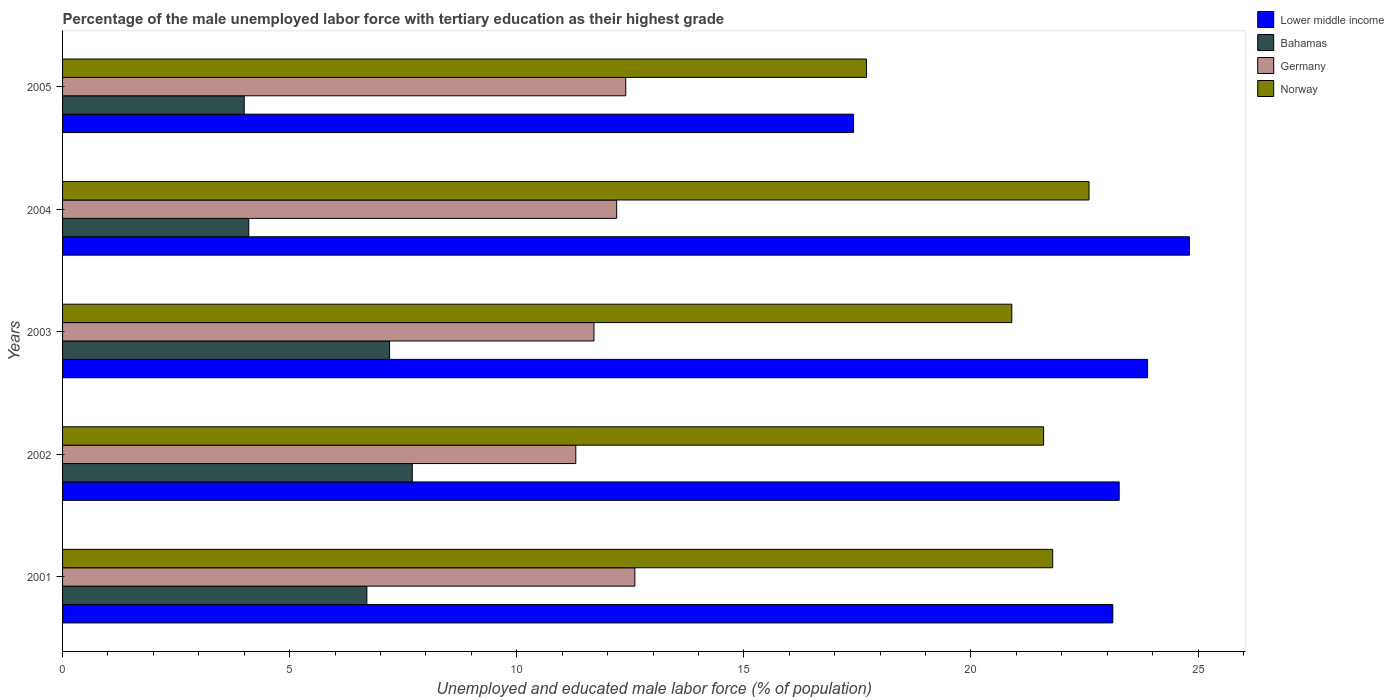How many groups of bars are there?
Your answer should be very brief. 5. Are the number of bars per tick equal to the number of legend labels?
Provide a succinct answer. Yes. Are the number of bars on each tick of the Y-axis equal?
Keep it short and to the point. Yes. How many bars are there on the 4th tick from the top?
Your answer should be very brief. 4. What is the percentage of the unemployed male labor force with tertiary education in Germany in 2002?
Provide a succinct answer. 11.3. Across all years, what is the maximum percentage of the unemployed male labor force with tertiary education in Germany?
Keep it short and to the point. 12.6. Across all years, what is the minimum percentage of the unemployed male labor force with tertiary education in Lower middle income?
Keep it short and to the point. 17.42. In which year was the percentage of the unemployed male labor force with tertiary education in Bahamas minimum?
Your answer should be compact. 2005. What is the total percentage of the unemployed male labor force with tertiary education in Germany in the graph?
Offer a terse response. 60.2. What is the difference between the percentage of the unemployed male labor force with tertiary education in Germany in 2004 and the percentage of the unemployed male labor force with tertiary education in Lower middle income in 2002?
Provide a short and direct response. -11.06. What is the average percentage of the unemployed male labor force with tertiary education in Bahamas per year?
Offer a terse response. 5.94. In the year 2005, what is the difference between the percentage of the unemployed male labor force with tertiary education in Norway and percentage of the unemployed male labor force with tertiary education in Germany?
Provide a succinct answer. 5.3. In how many years, is the percentage of the unemployed male labor force with tertiary education in Germany greater than 10 %?
Your answer should be very brief. 5. What is the ratio of the percentage of the unemployed male labor force with tertiary education in Norway in 2002 to that in 2005?
Offer a very short reply. 1.22. Is the percentage of the unemployed male labor force with tertiary education in Bahamas in 2002 less than that in 2003?
Make the answer very short. No. Is the difference between the percentage of the unemployed male labor force with tertiary education in Norway in 2001 and 2003 greater than the difference between the percentage of the unemployed male labor force with tertiary education in Germany in 2001 and 2003?
Provide a short and direct response. No. What is the difference between the highest and the second highest percentage of the unemployed male labor force with tertiary education in Germany?
Your answer should be very brief. 0.2. What is the difference between the highest and the lowest percentage of the unemployed male labor force with tertiary education in Norway?
Make the answer very short. 4.9. Is the sum of the percentage of the unemployed male labor force with tertiary education in Lower middle income in 2001 and 2002 greater than the maximum percentage of the unemployed male labor force with tertiary education in Norway across all years?
Your response must be concise. Yes. What does the 1st bar from the top in 2005 represents?
Keep it short and to the point. Norway. What does the 2nd bar from the bottom in 2001 represents?
Provide a succinct answer. Bahamas. Is it the case that in every year, the sum of the percentage of the unemployed male labor force with tertiary education in Germany and percentage of the unemployed male labor force with tertiary education in Norway is greater than the percentage of the unemployed male labor force with tertiary education in Lower middle income?
Your answer should be very brief. Yes. How many years are there in the graph?
Your response must be concise. 5. What is the difference between two consecutive major ticks on the X-axis?
Provide a short and direct response. 5. Are the values on the major ticks of X-axis written in scientific E-notation?
Provide a succinct answer. No. Does the graph contain any zero values?
Make the answer very short. No. How many legend labels are there?
Give a very brief answer. 4. What is the title of the graph?
Your answer should be compact. Percentage of the male unemployed labor force with tertiary education as their highest grade. Does "Trinidad and Tobago" appear as one of the legend labels in the graph?
Provide a succinct answer. No. What is the label or title of the X-axis?
Your response must be concise. Unemployed and educated male labor force (% of population). What is the label or title of the Y-axis?
Offer a very short reply. Years. What is the Unemployed and educated male labor force (% of population) of Lower middle income in 2001?
Offer a terse response. 23.12. What is the Unemployed and educated male labor force (% of population) of Bahamas in 2001?
Your answer should be very brief. 6.7. What is the Unemployed and educated male labor force (% of population) of Germany in 2001?
Your answer should be compact. 12.6. What is the Unemployed and educated male labor force (% of population) of Norway in 2001?
Provide a succinct answer. 21.8. What is the Unemployed and educated male labor force (% of population) in Lower middle income in 2002?
Your answer should be very brief. 23.26. What is the Unemployed and educated male labor force (% of population) in Bahamas in 2002?
Your response must be concise. 7.7. What is the Unemployed and educated male labor force (% of population) of Germany in 2002?
Your response must be concise. 11.3. What is the Unemployed and educated male labor force (% of population) in Norway in 2002?
Your answer should be very brief. 21.6. What is the Unemployed and educated male labor force (% of population) of Lower middle income in 2003?
Ensure brevity in your answer.  23.89. What is the Unemployed and educated male labor force (% of population) of Bahamas in 2003?
Provide a succinct answer. 7.2. What is the Unemployed and educated male labor force (% of population) in Germany in 2003?
Provide a short and direct response. 11.7. What is the Unemployed and educated male labor force (% of population) of Norway in 2003?
Your answer should be compact. 20.9. What is the Unemployed and educated male labor force (% of population) in Lower middle income in 2004?
Ensure brevity in your answer.  24.81. What is the Unemployed and educated male labor force (% of population) of Bahamas in 2004?
Your answer should be very brief. 4.1. What is the Unemployed and educated male labor force (% of population) of Germany in 2004?
Provide a succinct answer. 12.2. What is the Unemployed and educated male labor force (% of population) of Norway in 2004?
Ensure brevity in your answer.  22.6. What is the Unemployed and educated male labor force (% of population) in Lower middle income in 2005?
Your response must be concise. 17.42. What is the Unemployed and educated male labor force (% of population) in Bahamas in 2005?
Ensure brevity in your answer.  4. What is the Unemployed and educated male labor force (% of population) in Germany in 2005?
Provide a short and direct response. 12.4. What is the Unemployed and educated male labor force (% of population) of Norway in 2005?
Your response must be concise. 17.7. Across all years, what is the maximum Unemployed and educated male labor force (% of population) in Lower middle income?
Ensure brevity in your answer.  24.81. Across all years, what is the maximum Unemployed and educated male labor force (% of population) in Bahamas?
Provide a succinct answer. 7.7. Across all years, what is the maximum Unemployed and educated male labor force (% of population) in Germany?
Keep it short and to the point. 12.6. Across all years, what is the maximum Unemployed and educated male labor force (% of population) of Norway?
Keep it short and to the point. 22.6. Across all years, what is the minimum Unemployed and educated male labor force (% of population) of Lower middle income?
Provide a short and direct response. 17.42. Across all years, what is the minimum Unemployed and educated male labor force (% of population) of Germany?
Provide a succinct answer. 11.3. Across all years, what is the minimum Unemployed and educated male labor force (% of population) of Norway?
Your answer should be compact. 17.7. What is the total Unemployed and educated male labor force (% of population) in Lower middle income in the graph?
Give a very brief answer. 112.5. What is the total Unemployed and educated male labor force (% of population) of Bahamas in the graph?
Offer a terse response. 29.7. What is the total Unemployed and educated male labor force (% of population) in Germany in the graph?
Your response must be concise. 60.2. What is the total Unemployed and educated male labor force (% of population) of Norway in the graph?
Offer a terse response. 104.6. What is the difference between the Unemployed and educated male labor force (% of population) of Lower middle income in 2001 and that in 2002?
Make the answer very short. -0.14. What is the difference between the Unemployed and educated male labor force (% of population) in Bahamas in 2001 and that in 2002?
Keep it short and to the point. -1. What is the difference between the Unemployed and educated male labor force (% of population) of Lower middle income in 2001 and that in 2003?
Offer a terse response. -0.77. What is the difference between the Unemployed and educated male labor force (% of population) of Bahamas in 2001 and that in 2003?
Keep it short and to the point. -0.5. What is the difference between the Unemployed and educated male labor force (% of population) in Germany in 2001 and that in 2003?
Make the answer very short. 0.9. What is the difference between the Unemployed and educated male labor force (% of population) of Lower middle income in 2001 and that in 2004?
Provide a succinct answer. -1.69. What is the difference between the Unemployed and educated male labor force (% of population) of Bahamas in 2001 and that in 2004?
Your response must be concise. 2.6. What is the difference between the Unemployed and educated male labor force (% of population) in Germany in 2001 and that in 2004?
Your response must be concise. 0.4. What is the difference between the Unemployed and educated male labor force (% of population) of Lower middle income in 2001 and that in 2005?
Give a very brief answer. 5.71. What is the difference between the Unemployed and educated male labor force (% of population) of Germany in 2001 and that in 2005?
Offer a very short reply. 0.2. What is the difference between the Unemployed and educated male labor force (% of population) of Lower middle income in 2002 and that in 2003?
Your answer should be very brief. -0.62. What is the difference between the Unemployed and educated male labor force (% of population) in Bahamas in 2002 and that in 2003?
Provide a short and direct response. 0.5. What is the difference between the Unemployed and educated male labor force (% of population) in Norway in 2002 and that in 2003?
Your response must be concise. 0.7. What is the difference between the Unemployed and educated male labor force (% of population) in Lower middle income in 2002 and that in 2004?
Your answer should be very brief. -1.54. What is the difference between the Unemployed and educated male labor force (% of population) of Lower middle income in 2002 and that in 2005?
Your response must be concise. 5.85. What is the difference between the Unemployed and educated male labor force (% of population) in Norway in 2002 and that in 2005?
Your answer should be compact. 3.9. What is the difference between the Unemployed and educated male labor force (% of population) of Lower middle income in 2003 and that in 2004?
Ensure brevity in your answer.  -0.92. What is the difference between the Unemployed and educated male labor force (% of population) of Bahamas in 2003 and that in 2004?
Give a very brief answer. 3.1. What is the difference between the Unemployed and educated male labor force (% of population) in Norway in 2003 and that in 2004?
Provide a short and direct response. -1.7. What is the difference between the Unemployed and educated male labor force (% of population) of Lower middle income in 2003 and that in 2005?
Provide a succinct answer. 6.47. What is the difference between the Unemployed and educated male labor force (% of population) of Bahamas in 2003 and that in 2005?
Provide a succinct answer. 3.2. What is the difference between the Unemployed and educated male labor force (% of population) of Germany in 2003 and that in 2005?
Make the answer very short. -0.7. What is the difference between the Unemployed and educated male labor force (% of population) in Norway in 2003 and that in 2005?
Offer a terse response. 3.2. What is the difference between the Unemployed and educated male labor force (% of population) of Lower middle income in 2004 and that in 2005?
Ensure brevity in your answer.  7.39. What is the difference between the Unemployed and educated male labor force (% of population) of Germany in 2004 and that in 2005?
Provide a short and direct response. -0.2. What is the difference between the Unemployed and educated male labor force (% of population) in Lower middle income in 2001 and the Unemployed and educated male labor force (% of population) in Bahamas in 2002?
Ensure brevity in your answer.  15.42. What is the difference between the Unemployed and educated male labor force (% of population) of Lower middle income in 2001 and the Unemployed and educated male labor force (% of population) of Germany in 2002?
Offer a very short reply. 11.82. What is the difference between the Unemployed and educated male labor force (% of population) in Lower middle income in 2001 and the Unemployed and educated male labor force (% of population) in Norway in 2002?
Your response must be concise. 1.52. What is the difference between the Unemployed and educated male labor force (% of population) in Bahamas in 2001 and the Unemployed and educated male labor force (% of population) in Germany in 2002?
Your answer should be very brief. -4.6. What is the difference between the Unemployed and educated male labor force (% of population) of Bahamas in 2001 and the Unemployed and educated male labor force (% of population) of Norway in 2002?
Give a very brief answer. -14.9. What is the difference between the Unemployed and educated male labor force (% of population) in Germany in 2001 and the Unemployed and educated male labor force (% of population) in Norway in 2002?
Give a very brief answer. -9. What is the difference between the Unemployed and educated male labor force (% of population) of Lower middle income in 2001 and the Unemployed and educated male labor force (% of population) of Bahamas in 2003?
Provide a short and direct response. 15.92. What is the difference between the Unemployed and educated male labor force (% of population) of Lower middle income in 2001 and the Unemployed and educated male labor force (% of population) of Germany in 2003?
Make the answer very short. 11.42. What is the difference between the Unemployed and educated male labor force (% of population) in Lower middle income in 2001 and the Unemployed and educated male labor force (% of population) in Norway in 2003?
Keep it short and to the point. 2.22. What is the difference between the Unemployed and educated male labor force (% of population) in Bahamas in 2001 and the Unemployed and educated male labor force (% of population) in Germany in 2003?
Offer a terse response. -5. What is the difference between the Unemployed and educated male labor force (% of population) of Bahamas in 2001 and the Unemployed and educated male labor force (% of population) of Norway in 2003?
Make the answer very short. -14.2. What is the difference between the Unemployed and educated male labor force (% of population) of Lower middle income in 2001 and the Unemployed and educated male labor force (% of population) of Bahamas in 2004?
Give a very brief answer. 19.02. What is the difference between the Unemployed and educated male labor force (% of population) in Lower middle income in 2001 and the Unemployed and educated male labor force (% of population) in Germany in 2004?
Offer a very short reply. 10.92. What is the difference between the Unemployed and educated male labor force (% of population) in Lower middle income in 2001 and the Unemployed and educated male labor force (% of population) in Norway in 2004?
Provide a succinct answer. 0.52. What is the difference between the Unemployed and educated male labor force (% of population) in Bahamas in 2001 and the Unemployed and educated male labor force (% of population) in Germany in 2004?
Your answer should be compact. -5.5. What is the difference between the Unemployed and educated male labor force (% of population) in Bahamas in 2001 and the Unemployed and educated male labor force (% of population) in Norway in 2004?
Ensure brevity in your answer.  -15.9. What is the difference between the Unemployed and educated male labor force (% of population) in Germany in 2001 and the Unemployed and educated male labor force (% of population) in Norway in 2004?
Your response must be concise. -10. What is the difference between the Unemployed and educated male labor force (% of population) in Lower middle income in 2001 and the Unemployed and educated male labor force (% of population) in Bahamas in 2005?
Offer a terse response. 19.12. What is the difference between the Unemployed and educated male labor force (% of population) in Lower middle income in 2001 and the Unemployed and educated male labor force (% of population) in Germany in 2005?
Offer a very short reply. 10.72. What is the difference between the Unemployed and educated male labor force (% of population) of Lower middle income in 2001 and the Unemployed and educated male labor force (% of population) of Norway in 2005?
Offer a very short reply. 5.42. What is the difference between the Unemployed and educated male labor force (% of population) of Bahamas in 2001 and the Unemployed and educated male labor force (% of population) of Germany in 2005?
Ensure brevity in your answer.  -5.7. What is the difference between the Unemployed and educated male labor force (% of population) of Germany in 2001 and the Unemployed and educated male labor force (% of population) of Norway in 2005?
Give a very brief answer. -5.1. What is the difference between the Unemployed and educated male labor force (% of population) of Lower middle income in 2002 and the Unemployed and educated male labor force (% of population) of Bahamas in 2003?
Your answer should be very brief. 16.06. What is the difference between the Unemployed and educated male labor force (% of population) in Lower middle income in 2002 and the Unemployed and educated male labor force (% of population) in Germany in 2003?
Ensure brevity in your answer.  11.56. What is the difference between the Unemployed and educated male labor force (% of population) of Lower middle income in 2002 and the Unemployed and educated male labor force (% of population) of Norway in 2003?
Ensure brevity in your answer.  2.36. What is the difference between the Unemployed and educated male labor force (% of population) of Bahamas in 2002 and the Unemployed and educated male labor force (% of population) of Germany in 2003?
Provide a short and direct response. -4. What is the difference between the Unemployed and educated male labor force (% of population) of Lower middle income in 2002 and the Unemployed and educated male labor force (% of population) of Bahamas in 2004?
Offer a very short reply. 19.16. What is the difference between the Unemployed and educated male labor force (% of population) in Lower middle income in 2002 and the Unemployed and educated male labor force (% of population) in Germany in 2004?
Your response must be concise. 11.06. What is the difference between the Unemployed and educated male labor force (% of population) in Lower middle income in 2002 and the Unemployed and educated male labor force (% of population) in Norway in 2004?
Provide a succinct answer. 0.66. What is the difference between the Unemployed and educated male labor force (% of population) in Bahamas in 2002 and the Unemployed and educated male labor force (% of population) in Germany in 2004?
Give a very brief answer. -4.5. What is the difference between the Unemployed and educated male labor force (% of population) in Bahamas in 2002 and the Unemployed and educated male labor force (% of population) in Norway in 2004?
Your answer should be very brief. -14.9. What is the difference between the Unemployed and educated male labor force (% of population) in Lower middle income in 2002 and the Unemployed and educated male labor force (% of population) in Bahamas in 2005?
Offer a terse response. 19.26. What is the difference between the Unemployed and educated male labor force (% of population) in Lower middle income in 2002 and the Unemployed and educated male labor force (% of population) in Germany in 2005?
Your answer should be very brief. 10.86. What is the difference between the Unemployed and educated male labor force (% of population) of Lower middle income in 2002 and the Unemployed and educated male labor force (% of population) of Norway in 2005?
Your response must be concise. 5.56. What is the difference between the Unemployed and educated male labor force (% of population) of Bahamas in 2002 and the Unemployed and educated male labor force (% of population) of Germany in 2005?
Make the answer very short. -4.7. What is the difference between the Unemployed and educated male labor force (% of population) in Lower middle income in 2003 and the Unemployed and educated male labor force (% of population) in Bahamas in 2004?
Keep it short and to the point. 19.79. What is the difference between the Unemployed and educated male labor force (% of population) in Lower middle income in 2003 and the Unemployed and educated male labor force (% of population) in Germany in 2004?
Offer a terse response. 11.69. What is the difference between the Unemployed and educated male labor force (% of population) in Lower middle income in 2003 and the Unemployed and educated male labor force (% of population) in Norway in 2004?
Offer a very short reply. 1.29. What is the difference between the Unemployed and educated male labor force (% of population) in Bahamas in 2003 and the Unemployed and educated male labor force (% of population) in Germany in 2004?
Give a very brief answer. -5. What is the difference between the Unemployed and educated male labor force (% of population) of Bahamas in 2003 and the Unemployed and educated male labor force (% of population) of Norway in 2004?
Ensure brevity in your answer.  -15.4. What is the difference between the Unemployed and educated male labor force (% of population) in Germany in 2003 and the Unemployed and educated male labor force (% of population) in Norway in 2004?
Your answer should be compact. -10.9. What is the difference between the Unemployed and educated male labor force (% of population) of Lower middle income in 2003 and the Unemployed and educated male labor force (% of population) of Bahamas in 2005?
Keep it short and to the point. 19.89. What is the difference between the Unemployed and educated male labor force (% of population) of Lower middle income in 2003 and the Unemployed and educated male labor force (% of population) of Germany in 2005?
Your answer should be very brief. 11.49. What is the difference between the Unemployed and educated male labor force (% of population) of Lower middle income in 2003 and the Unemployed and educated male labor force (% of population) of Norway in 2005?
Offer a terse response. 6.19. What is the difference between the Unemployed and educated male labor force (% of population) of Bahamas in 2003 and the Unemployed and educated male labor force (% of population) of Germany in 2005?
Offer a terse response. -5.2. What is the difference between the Unemployed and educated male labor force (% of population) of Germany in 2003 and the Unemployed and educated male labor force (% of population) of Norway in 2005?
Offer a terse response. -6. What is the difference between the Unemployed and educated male labor force (% of population) of Lower middle income in 2004 and the Unemployed and educated male labor force (% of population) of Bahamas in 2005?
Make the answer very short. 20.81. What is the difference between the Unemployed and educated male labor force (% of population) in Lower middle income in 2004 and the Unemployed and educated male labor force (% of population) in Germany in 2005?
Make the answer very short. 12.41. What is the difference between the Unemployed and educated male labor force (% of population) of Lower middle income in 2004 and the Unemployed and educated male labor force (% of population) of Norway in 2005?
Your answer should be very brief. 7.11. What is the difference between the Unemployed and educated male labor force (% of population) in Bahamas in 2004 and the Unemployed and educated male labor force (% of population) in Germany in 2005?
Ensure brevity in your answer.  -8.3. What is the average Unemployed and educated male labor force (% of population) in Lower middle income per year?
Your answer should be compact. 22.5. What is the average Unemployed and educated male labor force (% of population) in Bahamas per year?
Your answer should be compact. 5.94. What is the average Unemployed and educated male labor force (% of population) of Germany per year?
Keep it short and to the point. 12.04. What is the average Unemployed and educated male labor force (% of population) of Norway per year?
Make the answer very short. 20.92. In the year 2001, what is the difference between the Unemployed and educated male labor force (% of population) of Lower middle income and Unemployed and educated male labor force (% of population) of Bahamas?
Ensure brevity in your answer.  16.42. In the year 2001, what is the difference between the Unemployed and educated male labor force (% of population) of Lower middle income and Unemployed and educated male labor force (% of population) of Germany?
Keep it short and to the point. 10.52. In the year 2001, what is the difference between the Unemployed and educated male labor force (% of population) in Lower middle income and Unemployed and educated male labor force (% of population) in Norway?
Your response must be concise. 1.32. In the year 2001, what is the difference between the Unemployed and educated male labor force (% of population) in Bahamas and Unemployed and educated male labor force (% of population) in Germany?
Keep it short and to the point. -5.9. In the year 2001, what is the difference between the Unemployed and educated male labor force (% of population) in Bahamas and Unemployed and educated male labor force (% of population) in Norway?
Give a very brief answer. -15.1. In the year 2002, what is the difference between the Unemployed and educated male labor force (% of population) in Lower middle income and Unemployed and educated male labor force (% of population) in Bahamas?
Provide a succinct answer. 15.56. In the year 2002, what is the difference between the Unemployed and educated male labor force (% of population) in Lower middle income and Unemployed and educated male labor force (% of population) in Germany?
Keep it short and to the point. 11.96. In the year 2002, what is the difference between the Unemployed and educated male labor force (% of population) of Lower middle income and Unemployed and educated male labor force (% of population) of Norway?
Provide a succinct answer. 1.66. In the year 2003, what is the difference between the Unemployed and educated male labor force (% of population) in Lower middle income and Unemployed and educated male labor force (% of population) in Bahamas?
Give a very brief answer. 16.69. In the year 2003, what is the difference between the Unemployed and educated male labor force (% of population) of Lower middle income and Unemployed and educated male labor force (% of population) of Germany?
Ensure brevity in your answer.  12.19. In the year 2003, what is the difference between the Unemployed and educated male labor force (% of population) of Lower middle income and Unemployed and educated male labor force (% of population) of Norway?
Your response must be concise. 2.99. In the year 2003, what is the difference between the Unemployed and educated male labor force (% of population) in Bahamas and Unemployed and educated male labor force (% of population) in Norway?
Make the answer very short. -13.7. In the year 2003, what is the difference between the Unemployed and educated male labor force (% of population) of Germany and Unemployed and educated male labor force (% of population) of Norway?
Offer a terse response. -9.2. In the year 2004, what is the difference between the Unemployed and educated male labor force (% of population) of Lower middle income and Unemployed and educated male labor force (% of population) of Bahamas?
Your response must be concise. 20.71. In the year 2004, what is the difference between the Unemployed and educated male labor force (% of population) in Lower middle income and Unemployed and educated male labor force (% of population) in Germany?
Your response must be concise. 12.61. In the year 2004, what is the difference between the Unemployed and educated male labor force (% of population) of Lower middle income and Unemployed and educated male labor force (% of population) of Norway?
Ensure brevity in your answer.  2.21. In the year 2004, what is the difference between the Unemployed and educated male labor force (% of population) in Bahamas and Unemployed and educated male labor force (% of population) in Norway?
Make the answer very short. -18.5. In the year 2004, what is the difference between the Unemployed and educated male labor force (% of population) in Germany and Unemployed and educated male labor force (% of population) in Norway?
Keep it short and to the point. -10.4. In the year 2005, what is the difference between the Unemployed and educated male labor force (% of population) of Lower middle income and Unemployed and educated male labor force (% of population) of Bahamas?
Make the answer very short. 13.42. In the year 2005, what is the difference between the Unemployed and educated male labor force (% of population) in Lower middle income and Unemployed and educated male labor force (% of population) in Germany?
Make the answer very short. 5.02. In the year 2005, what is the difference between the Unemployed and educated male labor force (% of population) in Lower middle income and Unemployed and educated male labor force (% of population) in Norway?
Give a very brief answer. -0.28. In the year 2005, what is the difference between the Unemployed and educated male labor force (% of population) in Bahamas and Unemployed and educated male labor force (% of population) in Norway?
Offer a terse response. -13.7. In the year 2005, what is the difference between the Unemployed and educated male labor force (% of population) in Germany and Unemployed and educated male labor force (% of population) in Norway?
Ensure brevity in your answer.  -5.3. What is the ratio of the Unemployed and educated male labor force (% of population) in Bahamas in 2001 to that in 2002?
Provide a short and direct response. 0.87. What is the ratio of the Unemployed and educated male labor force (% of population) of Germany in 2001 to that in 2002?
Provide a succinct answer. 1.11. What is the ratio of the Unemployed and educated male labor force (% of population) in Norway in 2001 to that in 2002?
Keep it short and to the point. 1.01. What is the ratio of the Unemployed and educated male labor force (% of population) in Lower middle income in 2001 to that in 2003?
Offer a very short reply. 0.97. What is the ratio of the Unemployed and educated male labor force (% of population) of Bahamas in 2001 to that in 2003?
Provide a short and direct response. 0.93. What is the ratio of the Unemployed and educated male labor force (% of population) of Germany in 2001 to that in 2003?
Keep it short and to the point. 1.08. What is the ratio of the Unemployed and educated male labor force (% of population) of Norway in 2001 to that in 2003?
Provide a succinct answer. 1.04. What is the ratio of the Unemployed and educated male labor force (% of population) of Lower middle income in 2001 to that in 2004?
Offer a terse response. 0.93. What is the ratio of the Unemployed and educated male labor force (% of population) of Bahamas in 2001 to that in 2004?
Provide a short and direct response. 1.63. What is the ratio of the Unemployed and educated male labor force (% of population) of Germany in 2001 to that in 2004?
Keep it short and to the point. 1.03. What is the ratio of the Unemployed and educated male labor force (% of population) in Norway in 2001 to that in 2004?
Ensure brevity in your answer.  0.96. What is the ratio of the Unemployed and educated male labor force (% of population) of Lower middle income in 2001 to that in 2005?
Provide a succinct answer. 1.33. What is the ratio of the Unemployed and educated male labor force (% of population) of Bahamas in 2001 to that in 2005?
Ensure brevity in your answer.  1.68. What is the ratio of the Unemployed and educated male labor force (% of population) in Germany in 2001 to that in 2005?
Ensure brevity in your answer.  1.02. What is the ratio of the Unemployed and educated male labor force (% of population) in Norway in 2001 to that in 2005?
Provide a short and direct response. 1.23. What is the ratio of the Unemployed and educated male labor force (% of population) in Lower middle income in 2002 to that in 2003?
Your answer should be compact. 0.97. What is the ratio of the Unemployed and educated male labor force (% of population) of Bahamas in 2002 to that in 2003?
Your response must be concise. 1.07. What is the ratio of the Unemployed and educated male labor force (% of population) in Germany in 2002 to that in 2003?
Your answer should be very brief. 0.97. What is the ratio of the Unemployed and educated male labor force (% of population) of Norway in 2002 to that in 2003?
Provide a short and direct response. 1.03. What is the ratio of the Unemployed and educated male labor force (% of population) of Lower middle income in 2002 to that in 2004?
Your answer should be very brief. 0.94. What is the ratio of the Unemployed and educated male labor force (% of population) in Bahamas in 2002 to that in 2004?
Your response must be concise. 1.88. What is the ratio of the Unemployed and educated male labor force (% of population) of Germany in 2002 to that in 2004?
Your answer should be compact. 0.93. What is the ratio of the Unemployed and educated male labor force (% of population) in Norway in 2002 to that in 2004?
Your response must be concise. 0.96. What is the ratio of the Unemployed and educated male labor force (% of population) of Lower middle income in 2002 to that in 2005?
Provide a short and direct response. 1.34. What is the ratio of the Unemployed and educated male labor force (% of population) of Bahamas in 2002 to that in 2005?
Provide a succinct answer. 1.93. What is the ratio of the Unemployed and educated male labor force (% of population) in Germany in 2002 to that in 2005?
Provide a succinct answer. 0.91. What is the ratio of the Unemployed and educated male labor force (% of population) of Norway in 2002 to that in 2005?
Give a very brief answer. 1.22. What is the ratio of the Unemployed and educated male labor force (% of population) in Lower middle income in 2003 to that in 2004?
Provide a short and direct response. 0.96. What is the ratio of the Unemployed and educated male labor force (% of population) of Bahamas in 2003 to that in 2004?
Ensure brevity in your answer.  1.76. What is the ratio of the Unemployed and educated male labor force (% of population) in Norway in 2003 to that in 2004?
Give a very brief answer. 0.92. What is the ratio of the Unemployed and educated male labor force (% of population) in Lower middle income in 2003 to that in 2005?
Provide a short and direct response. 1.37. What is the ratio of the Unemployed and educated male labor force (% of population) of Bahamas in 2003 to that in 2005?
Your answer should be compact. 1.8. What is the ratio of the Unemployed and educated male labor force (% of population) of Germany in 2003 to that in 2005?
Your answer should be very brief. 0.94. What is the ratio of the Unemployed and educated male labor force (% of population) in Norway in 2003 to that in 2005?
Ensure brevity in your answer.  1.18. What is the ratio of the Unemployed and educated male labor force (% of population) in Lower middle income in 2004 to that in 2005?
Your answer should be compact. 1.42. What is the ratio of the Unemployed and educated male labor force (% of population) in Bahamas in 2004 to that in 2005?
Provide a short and direct response. 1.02. What is the ratio of the Unemployed and educated male labor force (% of population) of Germany in 2004 to that in 2005?
Offer a terse response. 0.98. What is the ratio of the Unemployed and educated male labor force (% of population) of Norway in 2004 to that in 2005?
Your response must be concise. 1.28. What is the difference between the highest and the second highest Unemployed and educated male labor force (% of population) in Lower middle income?
Make the answer very short. 0.92. What is the difference between the highest and the second highest Unemployed and educated male labor force (% of population) in Germany?
Offer a terse response. 0.2. What is the difference between the highest and the lowest Unemployed and educated male labor force (% of population) of Lower middle income?
Provide a succinct answer. 7.39. What is the difference between the highest and the lowest Unemployed and educated male labor force (% of population) in Germany?
Provide a short and direct response. 1.3. What is the difference between the highest and the lowest Unemployed and educated male labor force (% of population) in Norway?
Offer a terse response. 4.9. 